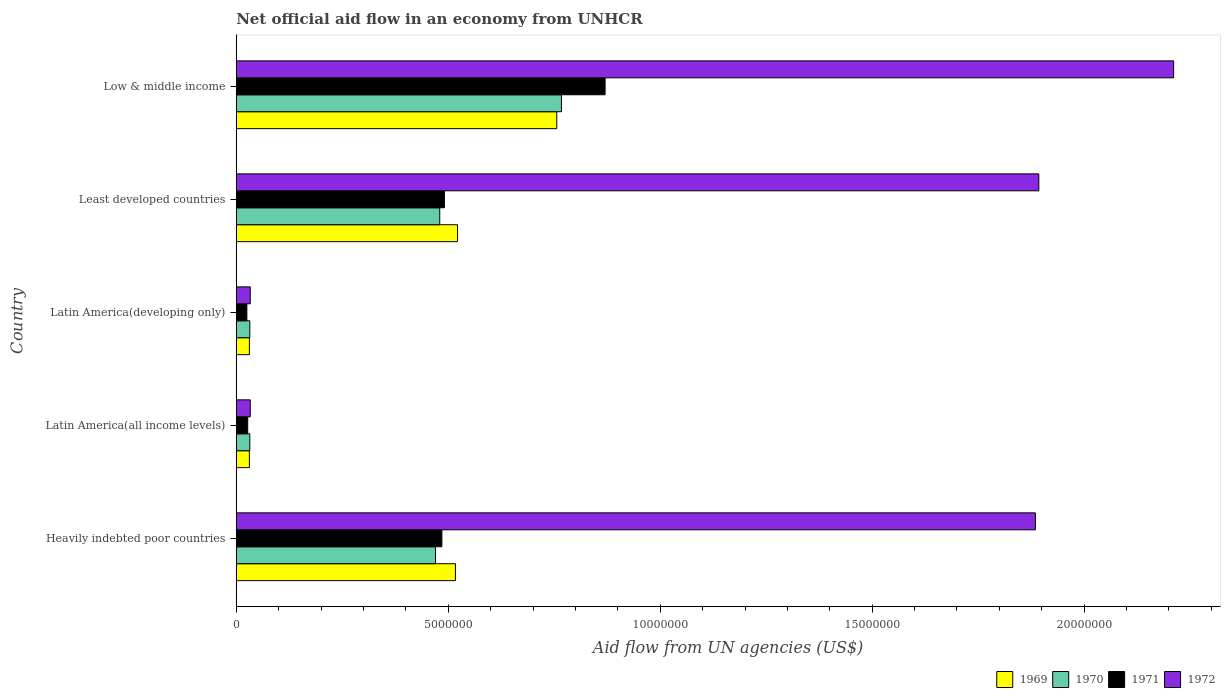How many groups of bars are there?
Make the answer very short. 5. How many bars are there on the 4th tick from the bottom?
Provide a succinct answer. 4. What is the label of the 3rd group of bars from the top?
Keep it short and to the point. Latin America(developing only). In how many cases, is the number of bars for a given country not equal to the number of legend labels?
Provide a short and direct response. 0. What is the net official aid flow in 1972 in Low & middle income?
Make the answer very short. 2.21e+07. Across all countries, what is the maximum net official aid flow in 1970?
Keep it short and to the point. 7.67e+06. In which country was the net official aid flow in 1971 minimum?
Provide a succinct answer. Latin America(developing only). What is the total net official aid flow in 1970 in the graph?
Your response must be concise. 1.78e+07. What is the difference between the net official aid flow in 1970 in Latin America(developing only) and that in Least developed countries?
Your response must be concise. -4.48e+06. What is the difference between the net official aid flow in 1970 in Heavily indebted poor countries and the net official aid flow in 1971 in Latin America(all income levels)?
Your answer should be compact. 4.43e+06. What is the average net official aid flow in 1969 per country?
Make the answer very short. 3.71e+06. What is the ratio of the net official aid flow in 1970 in Latin America(all income levels) to that in Least developed countries?
Make the answer very short. 0.07. Is the difference between the net official aid flow in 1969 in Heavily indebted poor countries and Latin America(all income levels) greater than the difference between the net official aid flow in 1972 in Heavily indebted poor countries and Latin America(all income levels)?
Your answer should be compact. No. What is the difference between the highest and the second highest net official aid flow in 1971?
Ensure brevity in your answer.  3.79e+06. What is the difference between the highest and the lowest net official aid flow in 1972?
Keep it short and to the point. 2.18e+07. In how many countries, is the net official aid flow in 1970 greater than the average net official aid flow in 1970 taken over all countries?
Give a very brief answer. 3. Are all the bars in the graph horizontal?
Keep it short and to the point. Yes. Are the values on the major ticks of X-axis written in scientific E-notation?
Offer a terse response. No. Does the graph contain any zero values?
Offer a very short reply. No. Does the graph contain grids?
Ensure brevity in your answer.  No. What is the title of the graph?
Provide a short and direct response. Net official aid flow in an economy from UNHCR. Does "2001" appear as one of the legend labels in the graph?
Ensure brevity in your answer.  No. What is the label or title of the X-axis?
Give a very brief answer. Aid flow from UN agencies (US$). What is the Aid flow from UN agencies (US$) in 1969 in Heavily indebted poor countries?
Your answer should be compact. 5.17e+06. What is the Aid flow from UN agencies (US$) in 1970 in Heavily indebted poor countries?
Make the answer very short. 4.70e+06. What is the Aid flow from UN agencies (US$) in 1971 in Heavily indebted poor countries?
Ensure brevity in your answer.  4.85e+06. What is the Aid flow from UN agencies (US$) of 1972 in Heavily indebted poor countries?
Provide a short and direct response. 1.88e+07. What is the Aid flow from UN agencies (US$) in 1969 in Latin America(all income levels)?
Provide a succinct answer. 3.10e+05. What is the Aid flow from UN agencies (US$) of 1971 in Latin America(all income levels)?
Give a very brief answer. 2.70e+05. What is the Aid flow from UN agencies (US$) of 1972 in Latin America(all income levels)?
Your response must be concise. 3.30e+05. What is the Aid flow from UN agencies (US$) of 1971 in Latin America(developing only)?
Provide a succinct answer. 2.50e+05. What is the Aid flow from UN agencies (US$) in 1969 in Least developed countries?
Provide a short and direct response. 5.22e+06. What is the Aid flow from UN agencies (US$) in 1970 in Least developed countries?
Provide a short and direct response. 4.80e+06. What is the Aid flow from UN agencies (US$) of 1971 in Least developed countries?
Your response must be concise. 4.91e+06. What is the Aid flow from UN agencies (US$) of 1972 in Least developed countries?
Provide a succinct answer. 1.89e+07. What is the Aid flow from UN agencies (US$) of 1969 in Low & middle income?
Your answer should be compact. 7.56e+06. What is the Aid flow from UN agencies (US$) of 1970 in Low & middle income?
Your response must be concise. 7.67e+06. What is the Aid flow from UN agencies (US$) in 1971 in Low & middle income?
Your answer should be compact. 8.70e+06. What is the Aid flow from UN agencies (US$) in 1972 in Low & middle income?
Make the answer very short. 2.21e+07. Across all countries, what is the maximum Aid flow from UN agencies (US$) of 1969?
Give a very brief answer. 7.56e+06. Across all countries, what is the maximum Aid flow from UN agencies (US$) in 1970?
Your answer should be compact. 7.67e+06. Across all countries, what is the maximum Aid flow from UN agencies (US$) in 1971?
Keep it short and to the point. 8.70e+06. Across all countries, what is the maximum Aid flow from UN agencies (US$) in 1972?
Make the answer very short. 2.21e+07. Across all countries, what is the minimum Aid flow from UN agencies (US$) in 1970?
Offer a very short reply. 3.20e+05. What is the total Aid flow from UN agencies (US$) of 1969 in the graph?
Ensure brevity in your answer.  1.86e+07. What is the total Aid flow from UN agencies (US$) in 1970 in the graph?
Your answer should be very brief. 1.78e+07. What is the total Aid flow from UN agencies (US$) in 1971 in the graph?
Your answer should be compact. 1.90e+07. What is the total Aid flow from UN agencies (US$) in 1972 in the graph?
Provide a succinct answer. 6.06e+07. What is the difference between the Aid flow from UN agencies (US$) in 1969 in Heavily indebted poor countries and that in Latin America(all income levels)?
Your response must be concise. 4.86e+06. What is the difference between the Aid flow from UN agencies (US$) in 1970 in Heavily indebted poor countries and that in Latin America(all income levels)?
Offer a terse response. 4.38e+06. What is the difference between the Aid flow from UN agencies (US$) of 1971 in Heavily indebted poor countries and that in Latin America(all income levels)?
Keep it short and to the point. 4.58e+06. What is the difference between the Aid flow from UN agencies (US$) of 1972 in Heavily indebted poor countries and that in Latin America(all income levels)?
Make the answer very short. 1.85e+07. What is the difference between the Aid flow from UN agencies (US$) in 1969 in Heavily indebted poor countries and that in Latin America(developing only)?
Keep it short and to the point. 4.86e+06. What is the difference between the Aid flow from UN agencies (US$) of 1970 in Heavily indebted poor countries and that in Latin America(developing only)?
Offer a very short reply. 4.38e+06. What is the difference between the Aid flow from UN agencies (US$) in 1971 in Heavily indebted poor countries and that in Latin America(developing only)?
Make the answer very short. 4.60e+06. What is the difference between the Aid flow from UN agencies (US$) in 1972 in Heavily indebted poor countries and that in Latin America(developing only)?
Your response must be concise. 1.85e+07. What is the difference between the Aid flow from UN agencies (US$) of 1970 in Heavily indebted poor countries and that in Least developed countries?
Offer a very short reply. -1.00e+05. What is the difference between the Aid flow from UN agencies (US$) of 1971 in Heavily indebted poor countries and that in Least developed countries?
Offer a terse response. -6.00e+04. What is the difference between the Aid flow from UN agencies (US$) in 1969 in Heavily indebted poor countries and that in Low & middle income?
Your answer should be compact. -2.39e+06. What is the difference between the Aid flow from UN agencies (US$) in 1970 in Heavily indebted poor countries and that in Low & middle income?
Your answer should be compact. -2.97e+06. What is the difference between the Aid flow from UN agencies (US$) of 1971 in Heavily indebted poor countries and that in Low & middle income?
Keep it short and to the point. -3.85e+06. What is the difference between the Aid flow from UN agencies (US$) of 1972 in Heavily indebted poor countries and that in Low & middle income?
Give a very brief answer. -3.26e+06. What is the difference between the Aid flow from UN agencies (US$) in 1969 in Latin America(all income levels) and that in Latin America(developing only)?
Provide a short and direct response. 0. What is the difference between the Aid flow from UN agencies (US$) in 1971 in Latin America(all income levels) and that in Latin America(developing only)?
Make the answer very short. 2.00e+04. What is the difference between the Aid flow from UN agencies (US$) of 1972 in Latin America(all income levels) and that in Latin America(developing only)?
Make the answer very short. 0. What is the difference between the Aid flow from UN agencies (US$) in 1969 in Latin America(all income levels) and that in Least developed countries?
Give a very brief answer. -4.91e+06. What is the difference between the Aid flow from UN agencies (US$) in 1970 in Latin America(all income levels) and that in Least developed countries?
Provide a short and direct response. -4.48e+06. What is the difference between the Aid flow from UN agencies (US$) in 1971 in Latin America(all income levels) and that in Least developed countries?
Provide a succinct answer. -4.64e+06. What is the difference between the Aid flow from UN agencies (US$) of 1972 in Latin America(all income levels) and that in Least developed countries?
Your response must be concise. -1.86e+07. What is the difference between the Aid flow from UN agencies (US$) in 1969 in Latin America(all income levels) and that in Low & middle income?
Offer a very short reply. -7.25e+06. What is the difference between the Aid flow from UN agencies (US$) in 1970 in Latin America(all income levels) and that in Low & middle income?
Ensure brevity in your answer.  -7.35e+06. What is the difference between the Aid flow from UN agencies (US$) in 1971 in Latin America(all income levels) and that in Low & middle income?
Ensure brevity in your answer.  -8.43e+06. What is the difference between the Aid flow from UN agencies (US$) in 1972 in Latin America(all income levels) and that in Low & middle income?
Provide a succinct answer. -2.18e+07. What is the difference between the Aid flow from UN agencies (US$) of 1969 in Latin America(developing only) and that in Least developed countries?
Your response must be concise. -4.91e+06. What is the difference between the Aid flow from UN agencies (US$) of 1970 in Latin America(developing only) and that in Least developed countries?
Your answer should be compact. -4.48e+06. What is the difference between the Aid flow from UN agencies (US$) of 1971 in Latin America(developing only) and that in Least developed countries?
Offer a very short reply. -4.66e+06. What is the difference between the Aid flow from UN agencies (US$) in 1972 in Latin America(developing only) and that in Least developed countries?
Make the answer very short. -1.86e+07. What is the difference between the Aid flow from UN agencies (US$) in 1969 in Latin America(developing only) and that in Low & middle income?
Give a very brief answer. -7.25e+06. What is the difference between the Aid flow from UN agencies (US$) of 1970 in Latin America(developing only) and that in Low & middle income?
Offer a very short reply. -7.35e+06. What is the difference between the Aid flow from UN agencies (US$) in 1971 in Latin America(developing only) and that in Low & middle income?
Give a very brief answer. -8.45e+06. What is the difference between the Aid flow from UN agencies (US$) of 1972 in Latin America(developing only) and that in Low & middle income?
Your answer should be very brief. -2.18e+07. What is the difference between the Aid flow from UN agencies (US$) of 1969 in Least developed countries and that in Low & middle income?
Keep it short and to the point. -2.34e+06. What is the difference between the Aid flow from UN agencies (US$) in 1970 in Least developed countries and that in Low & middle income?
Make the answer very short. -2.87e+06. What is the difference between the Aid flow from UN agencies (US$) in 1971 in Least developed countries and that in Low & middle income?
Keep it short and to the point. -3.79e+06. What is the difference between the Aid flow from UN agencies (US$) in 1972 in Least developed countries and that in Low & middle income?
Your answer should be very brief. -3.18e+06. What is the difference between the Aid flow from UN agencies (US$) in 1969 in Heavily indebted poor countries and the Aid flow from UN agencies (US$) in 1970 in Latin America(all income levels)?
Provide a short and direct response. 4.85e+06. What is the difference between the Aid flow from UN agencies (US$) of 1969 in Heavily indebted poor countries and the Aid flow from UN agencies (US$) of 1971 in Latin America(all income levels)?
Keep it short and to the point. 4.90e+06. What is the difference between the Aid flow from UN agencies (US$) in 1969 in Heavily indebted poor countries and the Aid flow from UN agencies (US$) in 1972 in Latin America(all income levels)?
Give a very brief answer. 4.84e+06. What is the difference between the Aid flow from UN agencies (US$) of 1970 in Heavily indebted poor countries and the Aid flow from UN agencies (US$) of 1971 in Latin America(all income levels)?
Ensure brevity in your answer.  4.43e+06. What is the difference between the Aid flow from UN agencies (US$) of 1970 in Heavily indebted poor countries and the Aid flow from UN agencies (US$) of 1972 in Latin America(all income levels)?
Ensure brevity in your answer.  4.37e+06. What is the difference between the Aid flow from UN agencies (US$) of 1971 in Heavily indebted poor countries and the Aid flow from UN agencies (US$) of 1972 in Latin America(all income levels)?
Keep it short and to the point. 4.52e+06. What is the difference between the Aid flow from UN agencies (US$) of 1969 in Heavily indebted poor countries and the Aid flow from UN agencies (US$) of 1970 in Latin America(developing only)?
Keep it short and to the point. 4.85e+06. What is the difference between the Aid flow from UN agencies (US$) in 1969 in Heavily indebted poor countries and the Aid flow from UN agencies (US$) in 1971 in Latin America(developing only)?
Provide a short and direct response. 4.92e+06. What is the difference between the Aid flow from UN agencies (US$) in 1969 in Heavily indebted poor countries and the Aid flow from UN agencies (US$) in 1972 in Latin America(developing only)?
Your response must be concise. 4.84e+06. What is the difference between the Aid flow from UN agencies (US$) in 1970 in Heavily indebted poor countries and the Aid flow from UN agencies (US$) in 1971 in Latin America(developing only)?
Keep it short and to the point. 4.45e+06. What is the difference between the Aid flow from UN agencies (US$) in 1970 in Heavily indebted poor countries and the Aid flow from UN agencies (US$) in 1972 in Latin America(developing only)?
Your response must be concise. 4.37e+06. What is the difference between the Aid flow from UN agencies (US$) in 1971 in Heavily indebted poor countries and the Aid flow from UN agencies (US$) in 1972 in Latin America(developing only)?
Keep it short and to the point. 4.52e+06. What is the difference between the Aid flow from UN agencies (US$) in 1969 in Heavily indebted poor countries and the Aid flow from UN agencies (US$) in 1970 in Least developed countries?
Your answer should be compact. 3.70e+05. What is the difference between the Aid flow from UN agencies (US$) of 1969 in Heavily indebted poor countries and the Aid flow from UN agencies (US$) of 1972 in Least developed countries?
Ensure brevity in your answer.  -1.38e+07. What is the difference between the Aid flow from UN agencies (US$) of 1970 in Heavily indebted poor countries and the Aid flow from UN agencies (US$) of 1972 in Least developed countries?
Provide a short and direct response. -1.42e+07. What is the difference between the Aid flow from UN agencies (US$) of 1971 in Heavily indebted poor countries and the Aid flow from UN agencies (US$) of 1972 in Least developed countries?
Ensure brevity in your answer.  -1.41e+07. What is the difference between the Aid flow from UN agencies (US$) in 1969 in Heavily indebted poor countries and the Aid flow from UN agencies (US$) in 1970 in Low & middle income?
Provide a succinct answer. -2.50e+06. What is the difference between the Aid flow from UN agencies (US$) of 1969 in Heavily indebted poor countries and the Aid flow from UN agencies (US$) of 1971 in Low & middle income?
Your answer should be compact. -3.53e+06. What is the difference between the Aid flow from UN agencies (US$) in 1969 in Heavily indebted poor countries and the Aid flow from UN agencies (US$) in 1972 in Low & middle income?
Provide a succinct answer. -1.69e+07. What is the difference between the Aid flow from UN agencies (US$) in 1970 in Heavily indebted poor countries and the Aid flow from UN agencies (US$) in 1972 in Low & middle income?
Provide a succinct answer. -1.74e+07. What is the difference between the Aid flow from UN agencies (US$) of 1971 in Heavily indebted poor countries and the Aid flow from UN agencies (US$) of 1972 in Low & middle income?
Ensure brevity in your answer.  -1.73e+07. What is the difference between the Aid flow from UN agencies (US$) in 1969 in Latin America(all income levels) and the Aid flow from UN agencies (US$) in 1971 in Latin America(developing only)?
Your answer should be compact. 6.00e+04. What is the difference between the Aid flow from UN agencies (US$) in 1969 in Latin America(all income levels) and the Aid flow from UN agencies (US$) in 1972 in Latin America(developing only)?
Provide a succinct answer. -2.00e+04. What is the difference between the Aid flow from UN agencies (US$) in 1969 in Latin America(all income levels) and the Aid flow from UN agencies (US$) in 1970 in Least developed countries?
Give a very brief answer. -4.49e+06. What is the difference between the Aid flow from UN agencies (US$) in 1969 in Latin America(all income levels) and the Aid flow from UN agencies (US$) in 1971 in Least developed countries?
Give a very brief answer. -4.60e+06. What is the difference between the Aid flow from UN agencies (US$) in 1969 in Latin America(all income levels) and the Aid flow from UN agencies (US$) in 1972 in Least developed countries?
Provide a short and direct response. -1.86e+07. What is the difference between the Aid flow from UN agencies (US$) of 1970 in Latin America(all income levels) and the Aid flow from UN agencies (US$) of 1971 in Least developed countries?
Your response must be concise. -4.59e+06. What is the difference between the Aid flow from UN agencies (US$) of 1970 in Latin America(all income levels) and the Aid flow from UN agencies (US$) of 1972 in Least developed countries?
Your response must be concise. -1.86e+07. What is the difference between the Aid flow from UN agencies (US$) in 1971 in Latin America(all income levels) and the Aid flow from UN agencies (US$) in 1972 in Least developed countries?
Keep it short and to the point. -1.87e+07. What is the difference between the Aid flow from UN agencies (US$) of 1969 in Latin America(all income levels) and the Aid flow from UN agencies (US$) of 1970 in Low & middle income?
Ensure brevity in your answer.  -7.36e+06. What is the difference between the Aid flow from UN agencies (US$) of 1969 in Latin America(all income levels) and the Aid flow from UN agencies (US$) of 1971 in Low & middle income?
Provide a succinct answer. -8.39e+06. What is the difference between the Aid flow from UN agencies (US$) of 1969 in Latin America(all income levels) and the Aid flow from UN agencies (US$) of 1972 in Low & middle income?
Offer a very short reply. -2.18e+07. What is the difference between the Aid flow from UN agencies (US$) of 1970 in Latin America(all income levels) and the Aid flow from UN agencies (US$) of 1971 in Low & middle income?
Your answer should be very brief. -8.38e+06. What is the difference between the Aid flow from UN agencies (US$) in 1970 in Latin America(all income levels) and the Aid flow from UN agencies (US$) in 1972 in Low & middle income?
Give a very brief answer. -2.18e+07. What is the difference between the Aid flow from UN agencies (US$) in 1971 in Latin America(all income levels) and the Aid flow from UN agencies (US$) in 1972 in Low & middle income?
Your response must be concise. -2.18e+07. What is the difference between the Aid flow from UN agencies (US$) of 1969 in Latin America(developing only) and the Aid flow from UN agencies (US$) of 1970 in Least developed countries?
Offer a very short reply. -4.49e+06. What is the difference between the Aid flow from UN agencies (US$) of 1969 in Latin America(developing only) and the Aid flow from UN agencies (US$) of 1971 in Least developed countries?
Make the answer very short. -4.60e+06. What is the difference between the Aid flow from UN agencies (US$) of 1969 in Latin America(developing only) and the Aid flow from UN agencies (US$) of 1972 in Least developed countries?
Your response must be concise. -1.86e+07. What is the difference between the Aid flow from UN agencies (US$) of 1970 in Latin America(developing only) and the Aid flow from UN agencies (US$) of 1971 in Least developed countries?
Give a very brief answer. -4.59e+06. What is the difference between the Aid flow from UN agencies (US$) in 1970 in Latin America(developing only) and the Aid flow from UN agencies (US$) in 1972 in Least developed countries?
Provide a succinct answer. -1.86e+07. What is the difference between the Aid flow from UN agencies (US$) in 1971 in Latin America(developing only) and the Aid flow from UN agencies (US$) in 1972 in Least developed countries?
Ensure brevity in your answer.  -1.87e+07. What is the difference between the Aid flow from UN agencies (US$) of 1969 in Latin America(developing only) and the Aid flow from UN agencies (US$) of 1970 in Low & middle income?
Ensure brevity in your answer.  -7.36e+06. What is the difference between the Aid flow from UN agencies (US$) of 1969 in Latin America(developing only) and the Aid flow from UN agencies (US$) of 1971 in Low & middle income?
Ensure brevity in your answer.  -8.39e+06. What is the difference between the Aid flow from UN agencies (US$) in 1969 in Latin America(developing only) and the Aid flow from UN agencies (US$) in 1972 in Low & middle income?
Offer a terse response. -2.18e+07. What is the difference between the Aid flow from UN agencies (US$) in 1970 in Latin America(developing only) and the Aid flow from UN agencies (US$) in 1971 in Low & middle income?
Ensure brevity in your answer.  -8.38e+06. What is the difference between the Aid flow from UN agencies (US$) of 1970 in Latin America(developing only) and the Aid flow from UN agencies (US$) of 1972 in Low & middle income?
Your answer should be compact. -2.18e+07. What is the difference between the Aid flow from UN agencies (US$) of 1971 in Latin America(developing only) and the Aid flow from UN agencies (US$) of 1972 in Low & middle income?
Make the answer very short. -2.19e+07. What is the difference between the Aid flow from UN agencies (US$) in 1969 in Least developed countries and the Aid flow from UN agencies (US$) in 1970 in Low & middle income?
Ensure brevity in your answer.  -2.45e+06. What is the difference between the Aid flow from UN agencies (US$) of 1969 in Least developed countries and the Aid flow from UN agencies (US$) of 1971 in Low & middle income?
Give a very brief answer. -3.48e+06. What is the difference between the Aid flow from UN agencies (US$) of 1969 in Least developed countries and the Aid flow from UN agencies (US$) of 1972 in Low & middle income?
Ensure brevity in your answer.  -1.69e+07. What is the difference between the Aid flow from UN agencies (US$) of 1970 in Least developed countries and the Aid flow from UN agencies (US$) of 1971 in Low & middle income?
Give a very brief answer. -3.90e+06. What is the difference between the Aid flow from UN agencies (US$) of 1970 in Least developed countries and the Aid flow from UN agencies (US$) of 1972 in Low & middle income?
Your response must be concise. -1.73e+07. What is the difference between the Aid flow from UN agencies (US$) of 1971 in Least developed countries and the Aid flow from UN agencies (US$) of 1972 in Low & middle income?
Keep it short and to the point. -1.72e+07. What is the average Aid flow from UN agencies (US$) of 1969 per country?
Give a very brief answer. 3.71e+06. What is the average Aid flow from UN agencies (US$) of 1970 per country?
Make the answer very short. 3.56e+06. What is the average Aid flow from UN agencies (US$) in 1971 per country?
Your answer should be compact. 3.80e+06. What is the average Aid flow from UN agencies (US$) in 1972 per country?
Ensure brevity in your answer.  1.21e+07. What is the difference between the Aid flow from UN agencies (US$) of 1969 and Aid flow from UN agencies (US$) of 1971 in Heavily indebted poor countries?
Offer a very short reply. 3.20e+05. What is the difference between the Aid flow from UN agencies (US$) in 1969 and Aid flow from UN agencies (US$) in 1972 in Heavily indebted poor countries?
Keep it short and to the point. -1.37e+07. What is the difference between the Aid flow from UN agencies (US$) of 1970 and Aid flow from UN agencies (US$) of 1972 in Heavily indebted poor countries?
Ensure brevity in your answer.  -1.42e+07. What is the difference between the Aid flow from UN agencies (US$) in 1971 and Aid flow from UN agencies (US$) in 1972 in Heavily indebted poor countries?
Make the answer very short. -1.40e+07. What is the difference between the Aid flow from UN agencies (US$) of 1969 and Aid flow from UN agencies (US$) of 1971 in Latin America(all income levels)?
Your answer should be compact. 4.00e+04. What is the difference between the Aid flow from UN agencies (US$) in 1969 and Aid flow from UN agencies (US$) in 1972 in Latin America(all income levels)?
Provide a short and direct response. -2.00e+04. What is the difference between the Aid flow from UN agencies (US$) of 1970 and Aid flow from UN agencies (US$) of 1972 in Latin America(all income levels)?
Offer a terse response. -10000. What is the difference between the Aid flow from UN agencies (US$) of 1969 and Aid flow from UN agencies (US$) of 1970 in Latin America(developing only)?
Your answer should be compact. -10000. What is the difference between the Aid flow from UN agencies (US$) in 1969 and Aid flow from UN agencies (US$) in 1971 in Latin America(developing only)?
Your answer should be very brief. 6.00e+04. What is the difference between the Aid flow from UN agencies (US$) in 1970 and Aid flow from UN agencies (US$) in 1971 in Latin America(developing only)?
Your answer should be very brief. 7.00e+04. What is the difference between the Aid flow from UN agencies (US$) of 1970 and Aid flow from UN agencies (US$) of 1972 in Latin America(developing only)?
Provide a succinct answer. -10000. What is the difference between the Aid flow from UN agencies (US$) of 1971 and Aid flow from UN agencies (US$) of 1972 in Latin America(developing only)?
Offer a terse response. -8.00e+04. What is the difference between the Aid flow from UN agencies (US$) in 1969 and Aid flow from UN agencies (US$) in 1970 in Least developed countries?
Ensure brevity in your answer.  4.20e+05. What is the difference between the Aid flow from UN agencies (US$) in 1969 and Aid flow from UN agencies (US$) in 1972 in Least developed countries?
Keep it short and to the point. -1.37e+07. What is the difference between the Aid flow from UN agencies (US$) of 1970 and Aid flow from UN agencies (US$) of 1971 in Least developed countries?
Make the answer very short. -1.10e+05. What is the difference between the Aid flow from UN agencies (US$) of 1970 and Aid flow from UN agencies (US$) of 1972 in Least developed countries?
Your answer should be very brief. -1.41e+07. What is the difference between the Aid flow from UN agencies (US$) of 1971 and Aid flow from UN agencies (US$) of 1972 in Least developed countries?
Provide a short and direct response. -1.40e+07. What is the difference between the Aid flow from UN agencies (US$) in 1969 and Aid flow from UN agencies (US$) in 1970 in Low & middle income?
Provide a succinct answer. -1.10e+05. What is the difference between the Aid flow from UN agencies (US$) of 1969 and Aid flow from UN agencies (US$) of 1971 in Low & middle income?
Your answer should be very brief. -1.14e+06. What is the difference between the Aid flow from UN agencies (US$) of 1969 and Aid flow from UN agencies (US$) of 1972 in Low & middle income?
Offer a terse response. -1.46e+07. What is the difference between the Aid flow from UN agencies (US$) in 1970 and Aid flow from UN agencies (US$) in 1971 in Low & middle income?
Offer a very short reply. -1.03e+06. What is the difference between the Aid flow from UN agencies (US$) of 1970 and Aid flow from UN agencies (US$) of 1972 in Low & middle income?
Offer a very short reply. -1.44e+07. What is the difference between the Aid flow from UN agencies (US$) in 1971 and Aid flow from UN agencies (US$) in 1972 in Low & middle income?
Keep it short and to the point. -1.34e+07. What is the ratio of the Aid flow from UN agencies (US$) of 1969 in Heavily indebted poor countries to that in Latin America(all income levels)?
Provide a succinct answer. 16.68. What is the ratio of the Aid flow from UN agencies (US$) of 1970 in Heavily indebted poor countries to that in Latin America(all income levels)?
Offer a terse response. 14.69. What is the ratio of the Aid flow from UN agencies (US$) of 1971 in Heavily indebted poor countries to that in Latin America(all income levels)?
Keep it short and to the point. 17.96. What is the ratio of the Aid flow from UN agencies (US$) of 1972 in Heavily indebted poor countries to that in Latin America(all income levels)?
Ensure brevity in your answer.  57.12. What is the ratio of the Aid flow from UN agencies (US$) of 1969 in Heavily indebted poor countries to that in Latin America(developing only)?
Provide a short and direct response. 16.68. What is the ratio of the Aid flow from UN agencies (US$) of 1970 in Heavily indebted poor countries to that in Latin America(developing only)?
Make the answer very short. 14.69. What is the ratio of the Aid flow from UN agencies (US$) of 1972 in Heavily indebted poor countries to that in Latin America(developing only)?
Provide a succinct answer. 57.12. What is the ratio of the Aid flow from UN agencies (US$) in 1969 in Heavily indebted poor countries to that in Least developed countries?
Offer a very short reply. 0.99. What is the ratio of the Aid flow from UN agencies (US$) in 1970 in Heavily indebted poor countries to that in Least developed countries?
Your answer should be compact. 0.98. What is the ratio of the Aid flow from UN agencies (US$) in 1972 in Heavily indebted poor countries to that in Least developed countries?
Your response must be concise. 1. What is the ratio of the Aid flow from UN agencies (US$) of 1969 in Heavily indebted poor countries to that in Low & middle income?
Offer a very short reply. 0.68. What is the ratio of the Aid flow from UN agencies (US$) in 1970 in Heavily indebted poor countries to that in Low & middle income?
Your answer should be very brief. 0.61. What is the ratio of the Aid flow from UN agencies (US$) in 1971 in Heavily indebted poor countries to that in Low & middle income?
Your answer should be compact. 0.56. What is the ratio of the Aid flow from UN agencies (US$) in 1972 in Heavily indebted poor countries to that in Low & middle income?
Your response must be concise. 0.85. What is the ratio of the Aid flow from UN agencies (US$) of 1969 in Latin America(all income levels) to that in Latin America(developing only)?
Offer a very short reply. 1. What is the ratio of the Aid flow from UN agencies (US$) in 1970 in Latin America(all income levels) to that in Latin America(developing only)?
Provide a short and direct response. 1. What is the ratio of the Aid flow from UN agencies (US$) in 1969 in Latin America(all income levels) to that in Least developed countries?
Ensure brevity in your answer.  0.06. What is the ratio of the Aid flow from UN agencies (US$) of 1970 in Latin America(all income levels) to that in Least developed countries?
Your answer should be compact. 0.07. What is the ratio of the Aid flow from UN agencies (US$) of 1971 in Latin America(all income levels) to that in Least developed countries?
Your answer should be very brief. 0.06. What is the ratio of the Aid flow from UN agencies (US$) in 1972 in Latin America(all income levels) to that in Least developed countries?
Ensure brevity in your answer.  0.02. What is the ratio of the Aid flow from UN agencies (US$) of 1969 in Latin America(all income levels) to that in Low & middle income?
Make the answer very short. 0.04. What is the ratio of the Aid flow from UN agencies (US$) in 1970 in Latin America(all income levels) to that in Low & middle income?
Offer a very short reply. 0.04. What is the ratio of the Aid flow from UN agencies (US$) of 1971 in Latin America(all income levels) to that in Low & middle income?
Your answer should be very brief. 0.03. What is the ratio of the Aid flow from UN agencies (US$) of 1972 in Latin America(all income levels) to that in Low & middle income?
Provide a succinct answer. 0.01. What is the ratio of the Aid flow from UN agencies (US$) of 1969 in Latin America(developing only) to that in Least developed countries?
Offer a terse response. 0.06. What is the ratio of the Aid flow from UN agencies (US$) of 1970 in Latin America(developing only) to that in Least developed countries?
Give a very brief answer. 0.07. What is the ratio of the Aid flow from UN agencies (US$) in 1971 in Latin America(developing only) to that in Least developed countries?
Offer a terse response. 0.05. What is the ratio of the Aid flow from UN agencies (US$) in 1972 in Latin America(developing only) to that in Least developed countries?
Provide a succinct answer. 0.02. What is the ratio of the Aid flow from UN agencies (US$) of 1969 in Latin America(developing only) to that in Low & middle income?
Provide a succinct answer. 0.04. What is the ratio of the Aid flow from UN agencies (US$) in 1970 in Latin America(developing only) to that in Low & middle income?
Make the answer very short. 0.04. What is the ratio of the Aid flow from UN agencies (US$) in 1971 in Latin America(developing only) to that in Low & middle income?
Your response must be concise. 0.03. What is the ratio of the Aid flow from UN agencies (US$) of 1972 in Latin America(developing only) to that in Low & middle income?
Make the answer very short. 0.01. What is the ratio of the Aid flow from UN agencies (US$) of 1969 in Least developed countries to that in Low & middle income?
Ensure brevity in your answer.  0.69. What is the ratio of the Aid flow from UN agencies (US$) in 1970 in Least developed countries to that in Low & middle income?
Your answer should be very brief. 0.63. What is the ratio of the Aid flow from UN agencies (US$) of 1971 in Least developed countries to that in Low & middle income?
Give a very brief answer. 0.56. What is the ratio of the Aid flow from UN agencies (US$) in 1972 in Least developed countries to that in Low & middle income?
Ensure brevity in your answer.  0.86. What is the difference between the highest and the second highest Aid flow from UN agencies (US$) in 1969?
Offer a very short reply. 2.34e+06. What is the difference between the highest and the second highest Aid flow from UN agencies (US$) of 1970?
Give a very brief answer. 2.87e+06. What is the difference between the highest and the second highest Aid flow from UN agencies (US$) of 1971?
Provide a short and direct response. 3.79e+06. What is the difference between the highest and the second highest Aid flow from UN agencies (US$) in 1972?
Provide a succinct answer. 3.18e+06. What is the difference between the highest and the lowest Aid flow from UN agencies (US$) in 1969?
Make the answer very short. 7.25e+06. What is the difference between the highest and the lowest Aid flow from UN agencies (US$) in 1970?
Your answer should be very brief. 7.35e+06. What is the difference between the highest and the lowest Aid flow from UN agencies (US$) of 1971?
Ensure brevity in your answer.  8.45e+06. What is the difference between the highest and the lowest Aid flow from UN agencies (US$) in 1972?
Your answer should be compact. 2.18e+07. 